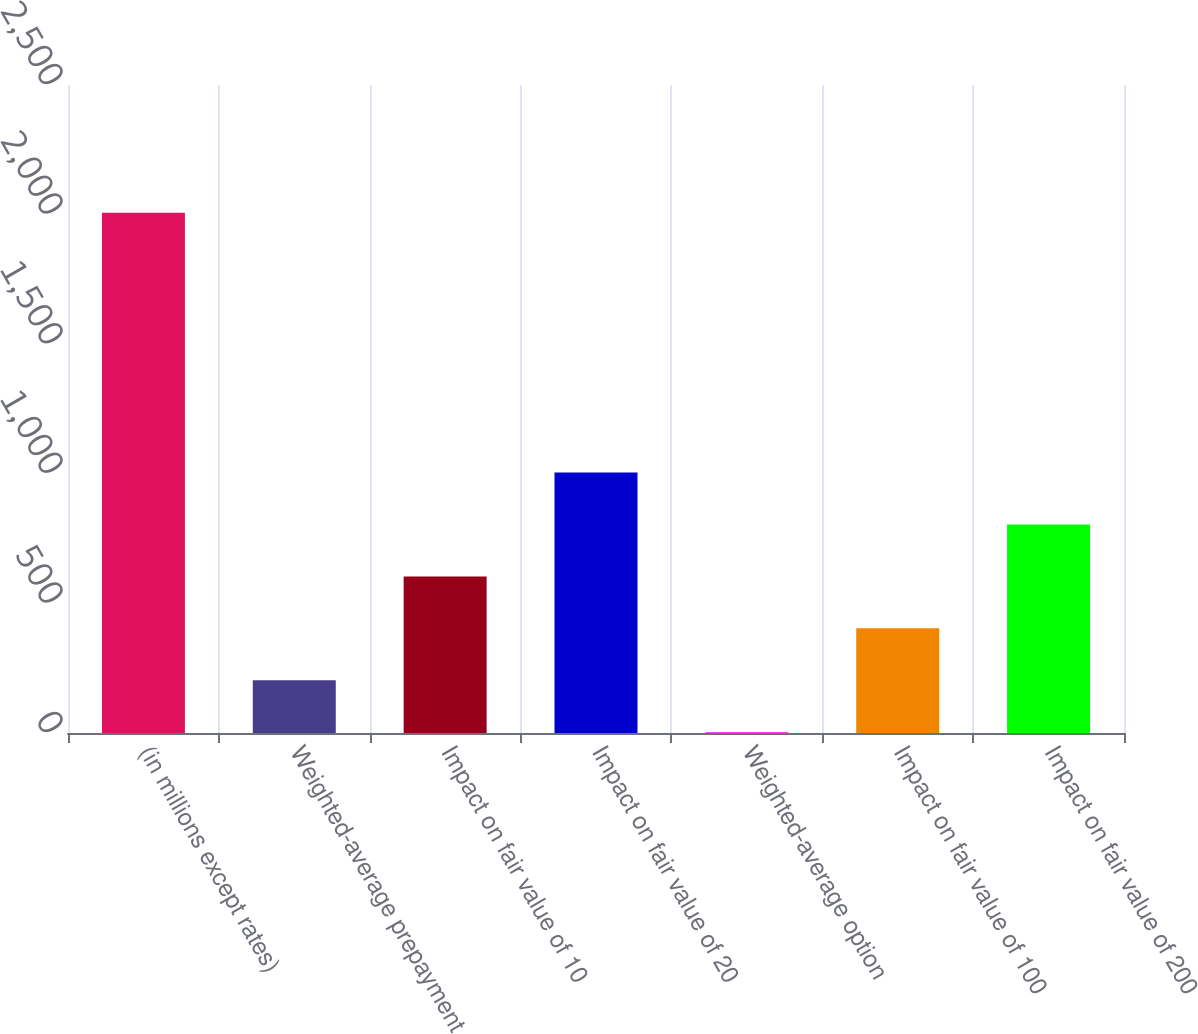Convert chart to OTSL. <chart><loc_0><loc_0><loc_500><loc_500><bar_chart><fcel>(in millions except rates)<fcel>Weighted-average prepayment<fcel>Impact on fair value of 10<fcel>Impact on fair value of 20<fcel>Weighted-average option<fcel>Impact on fair value of 100<fcel>Impact on fair value of 200<nl><fcel>2007<fcel>203.4<fcel>604.2<fcel>1005<fcel>3<fcel>403.8<fcel>804.6<nl></chart> 